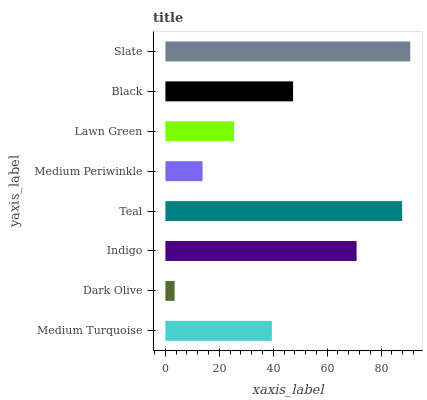Is Dark Olive the minimum?
Answer yes or no. Yes. Is Slate the maximum?
Answer yes or no. Yes. Is Indigo the minimum?
Answer yes or no. No. Is Indigo the maximum?
Answer yes or no. No. Is Indigo greater than Dark Olive?
Answer yes or no. Yes. Is Dark Olive less than Indigo?
Answer yes or no. Yes. Is Dark Olive greater than Indigo?
Answer yes or no. No. Is Indigo less than Dark Olive?
Answer yes or no. No. Is Black the high median?
Answer yes or no. Yes. Is Medium Turquoise the low median?
Answer yes or no. Yes. Is Teal the high median?
Answer yes or no. No. Is Medium Periwinkle the low median?
Answer yes or no. No. 